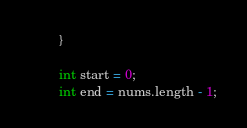Convert code to text. <code><loc_0><loc_0><loc_500><loc_500><_Java_>        }

        int start = 0;
        int end = nums.length - 1;
</code> 